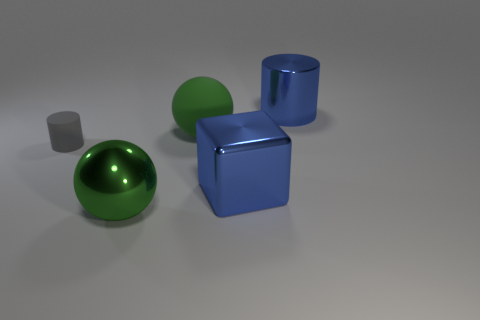Add 2 big blue shiny cylinders. How many objects exist? 7 Subtract all spheres. How many objects are left? 3 Subtract all balls. Subtract all gray matte cylinders. How many objects are left? 2 Add 3 large blue cylinders. How many large blue cylinders are left? 4 Add 2 small gray matte cylinders. How many small gray matte cylinders exist? 3 Subtract 0 red cylinders. How many objects are left? 5 